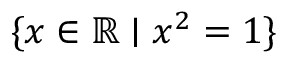Convert formula to latex. <formula><loc_0><loc_0><loc_500><loc_500>\{ x \in \mathbb { R } | x ^ { 2 } = 1 \}</formula> 